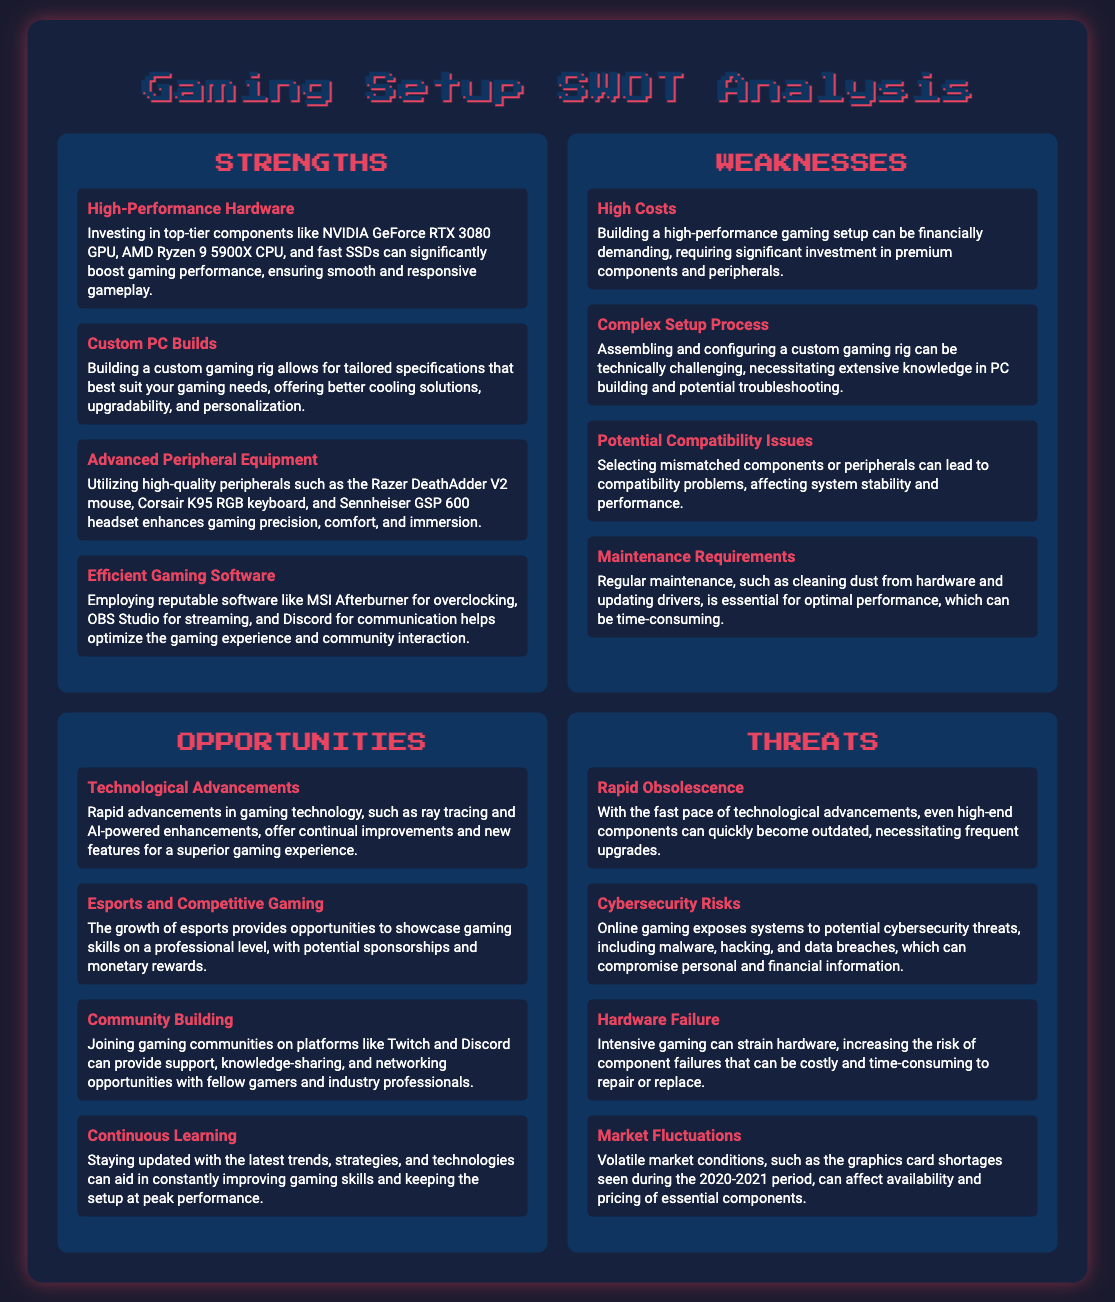what is a high-performance GPU mentioned in the strengths? The document lists NVIDIA GeForce RTX 3080 as a high-performance GPU in the strengths section.
Answer: NVIDIA GeForce RTX 3080 what is one advantage of custom PC builds? One advantage mentioned in the strengths section is that they allow for tailored specifications that best suit gaming needs.
Answer: Tailored specifications what is a common weakness related to the costs of building a gaming setup? The document states that building a high-performance gaming setup can be financially demanding, indicating high costs as a common weakness.
Answer: High Costs what are two types of software recommended for optimizing gaming experience? The strengths section advises using MSI Afterburner and OBS Studio for optimizing the gaming experience.
Answer: MSI Afterburner, OBS Studio what is one opportunity provided by the growth of esports? The document mentions that the growth of esports provides opportunities to showcase gaming skills on a professional level.
Answer: Showcase gaming skills what is a major threat mentioned regarding hardware? The document indicates that intensive gaming can strain hardware, leading to an increased risk of component failures as a major threat.
Answer: Hardware Failure how many weaknesses are listed in the document? The weaknesses section contains a total of four weaknesses related to building a gaming setup.
Answer: Four what is one benefit of community building in gaming? The document points out that joining gaming communities can provide support and knowledge-sharing, highlighting the benefits of community building in gaming.
Answer: Support and knowledge-sharing what does the document suggest about technological advancements? The document suggests that rapid advancements in gaming technology continually improve and provide new features for gaming.
Answer: Continual improvements and new features 